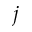Convert formula to latex. <formula><loc_0><loc_0><loc_500><loc_500>j</formula> 